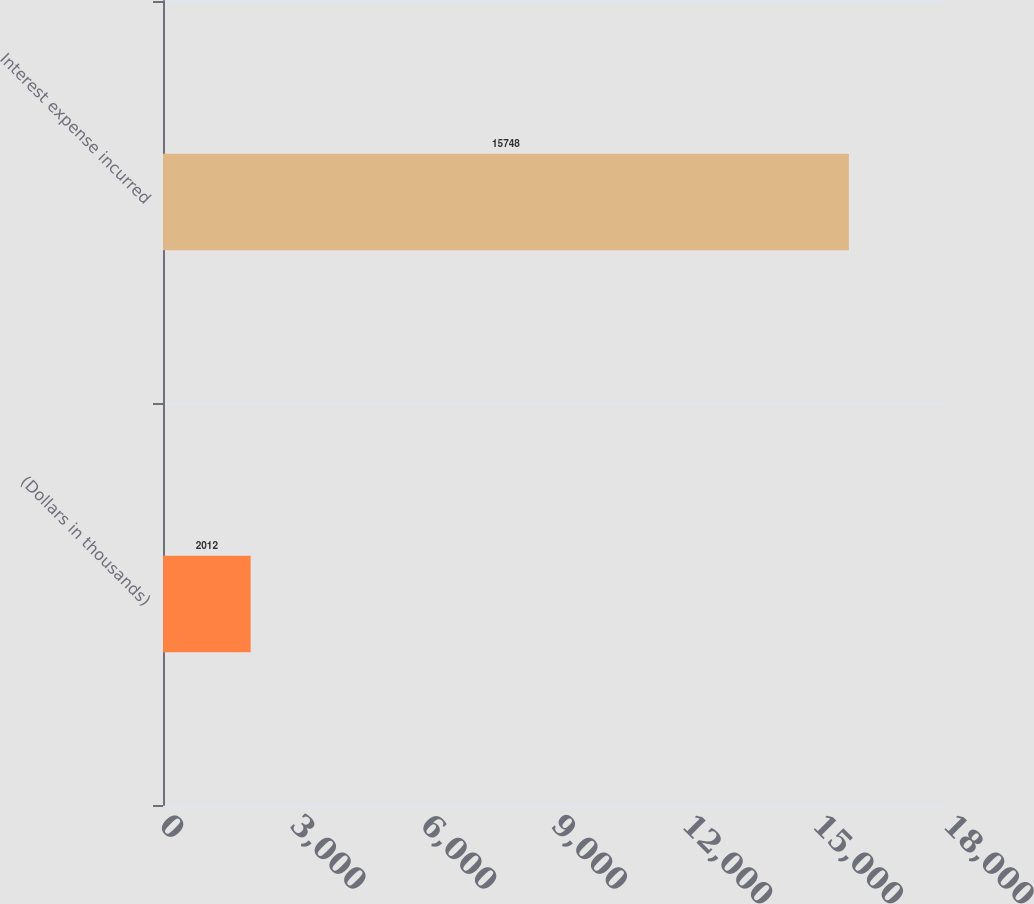Convert chart. <chart><loc_0><loc_0><loc_500><loc_500><bar_chart><fcel>(Dollars in thousands)<fcel>Interest expense incurred<nl><fcel>2012<fcel>15748<nl></chart> 